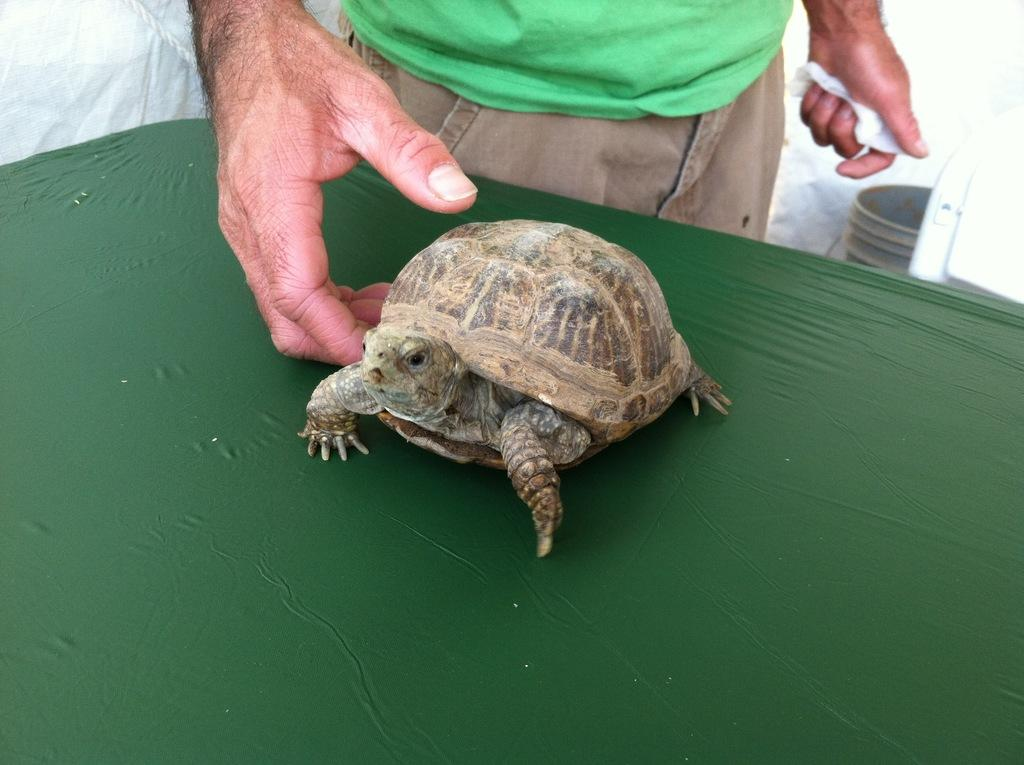What animal is present in the image? There is a tortoise in the image. Where is the tortoise located? The tortoise is placed on a table. What is the color of the table? The table is dark green in color. Can you describe the person in the image? There is a person standing in the image. What other object can be seen in the image? There appears to be a bucket in the image. What is the color of the background? The background of the image is white in color. How does the tortoise kiss the person in the image? There is no kissing depicted in the image; the tortoise and person are not interacting in that way. 